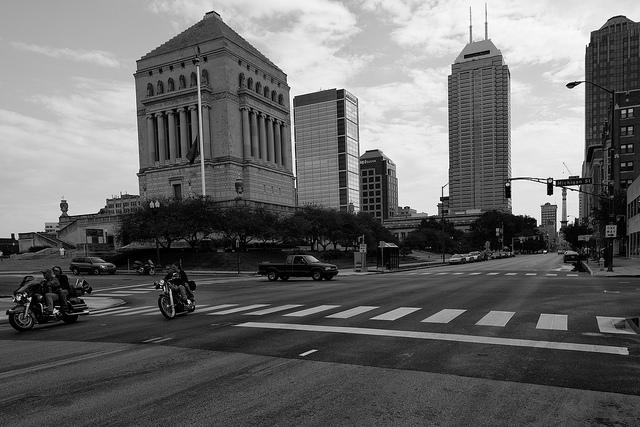What did the motorcycle near the crosswalk just do? Please explain your reasoning. turn. The motorcycle turns. 